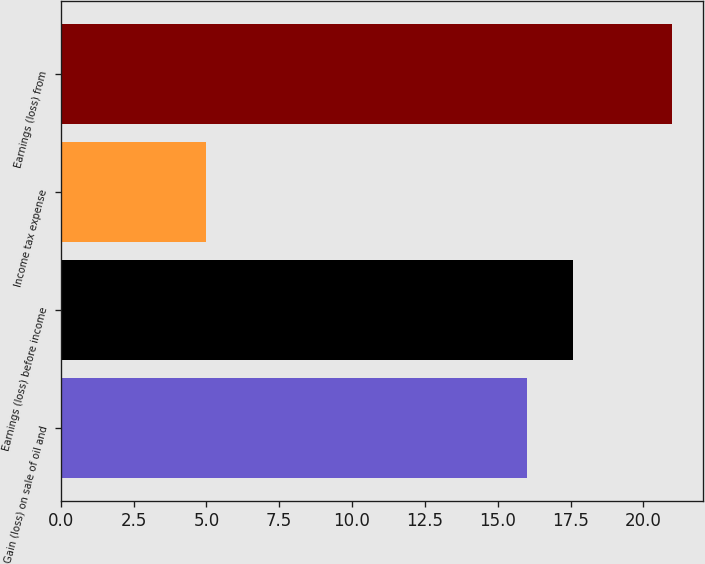Convert chart. <chart><loc_0><loc_0><loc_500><loc_500><bar_chart><fcel>Gain (loss) on sale of oil and<fcel>Earnings (loss) before income<fcel>Income tax expense<fcel>Earnings (loss) from<nl><fcel>16<fcel>17.6<fcel>5<fcel>21<nl></chart> 